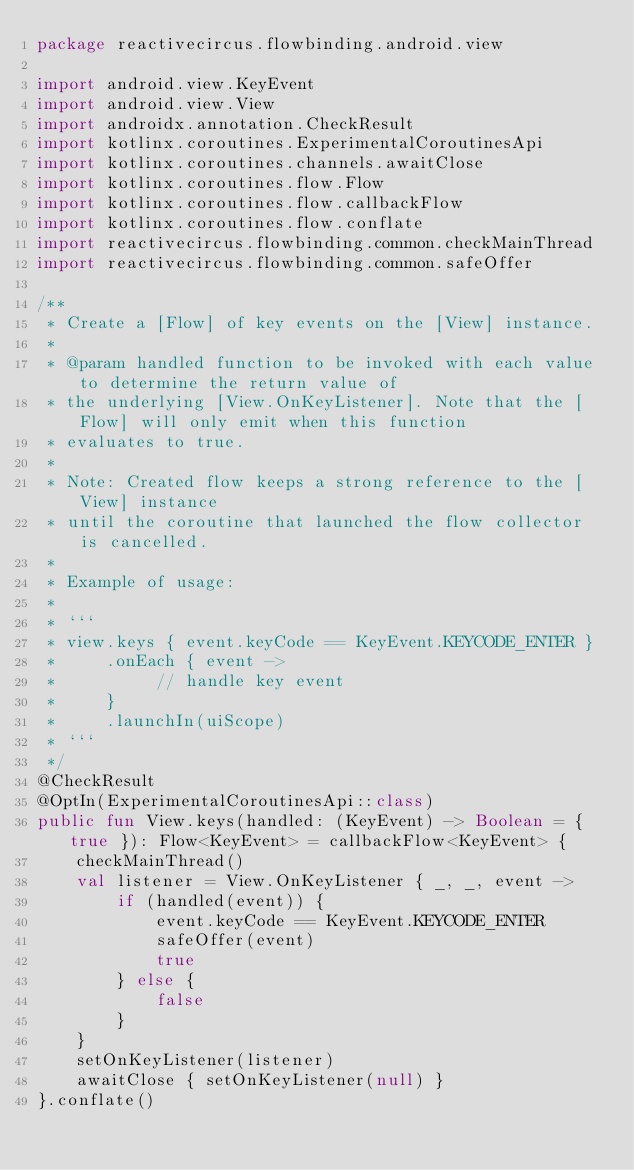<code> <loc_0><loc_0><loc_500><loc_500><_Kotlin_>package reactivecircus.flowbinding.android.view

import android.view.KeyEvent
import android.view.View
import androidx.annotation.CheckResult
import kotlinx.coroutines.ExperimentalCoroutinesApi
import kotlinx.coroutines.channels.awaitClose
import kotlinx.coroutines.flow.Flow
import kotlinx.coroutines.flow.callbackFlow
import kotlinx.coroutines.flow.conflate
import reactivecircus.flowbinding.common.checkMainThread
import reactivecircus.flowbinding.common.safeOffer

/**
 * Create a [Flow] of key events on the [View] instance.
 *
 * @param handled function to be invoked with each value to determine the return value of
 * the underlying [View.OnKeyListener]. Note that the [Flow] will only emit when this function
 * evaluates to true.
 *
 * Note: Created flow keeps a strong reference to the [View] instance
 * until the coroutine that launched the flow collector is cancelled.
 *
 * Example of usage:
 *
 * ```
 * view.keys { event.keyCode == KeyEvent.KEYCODE_ENTER }
 *     .onEach { event ->
 *          // handle key event
 *     }
 *     .launchIn(uiScope)
 * ```
 */
@CheckResult
@OptIn(ExperimentalCoroutinesApi::class)
public fun View.keys(handled: (KeyEvent) -> Boolean = { true }): Flow<KeyEvent> = callbackFlow<KeyEvent> {
    checkMainThread()
    val listener = View.OnKeyListener { _, _, event ->
        if (handled(event)) {
            event.keyCode == KeyEvent.KEYCODE_ENTER
            safeOffer(event)
            true
        } else {
            false
        }
    }
    setOnKeyListener(listener)
    awaitClose { setOnKeyListener(null) }
}.conflate()
</code> 